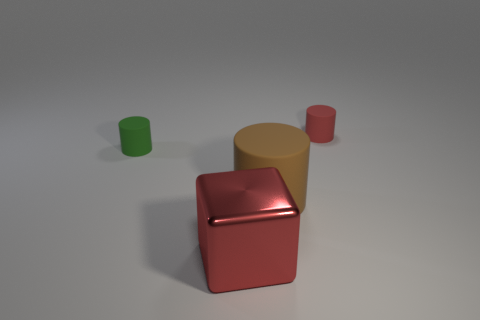There is a green object that is the same material as the small red thing; what is its size? small 